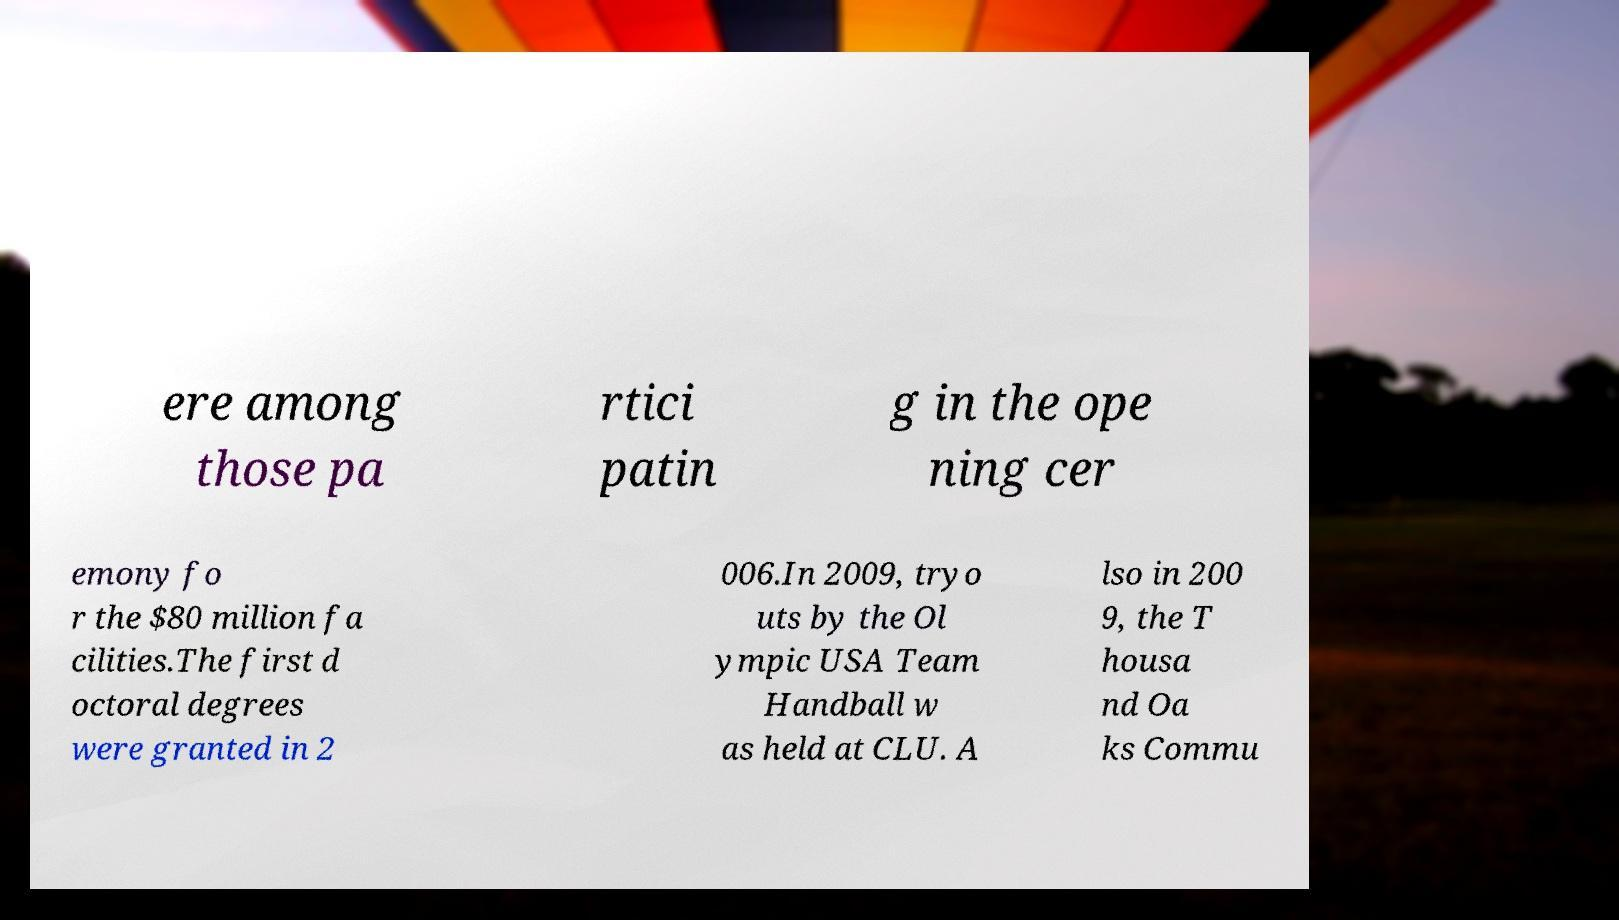There's text embedded in this image that I need extracted. Can you transcribe it verbatim? ere among those pa rtici patin g in the ope ning cer emony fo r the $80 million fa cilities.The first d octoral degrees were granted in 2 006.In 2009, tryo uts by the Ol ympic USA Team Handball w as held at CLU. A lso in 200 9, the T housa nd Oa ks Commu 